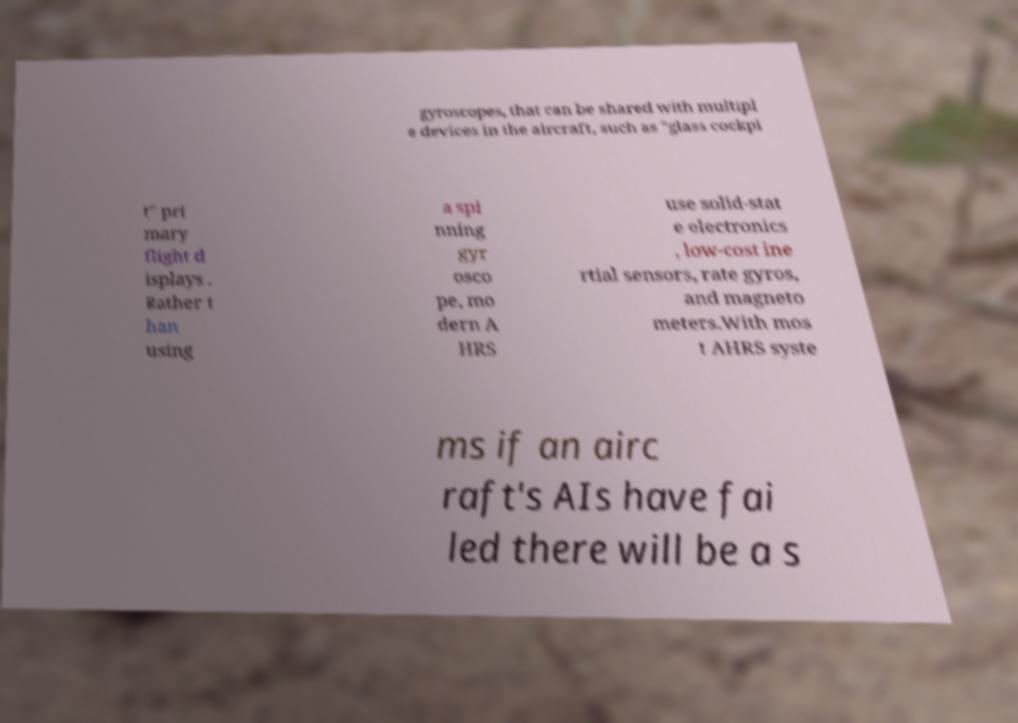What messages or text are displayed in this image? I need them in a readable, typed format. gyroscopes, that can be shared with multipl e devices in the aircraft, such as "glass cockpi t" pri mary flight d isplays . Rather t han using a spi nning gyr osco pe, mo dern A HRS use solid-stat e electronics , low-cost ine rtial sensors, rate gyros, and magneto meters.With mos t AHRS syste ms if an airc raft's AIs have fai led there will be a s 